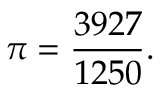<formula> <loc_0><loc_0><loc_500><loc_500>\pi = { \frac { 3 9 2 7 } { 1 2 5 0 } } .</formula> 